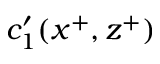Convert formula to latex. <formula><loc_0><loc_0><loc_500><loc_500>c _ { 1 } ^ { \prime } ( x ^ { + } , z ^ { + } )</formula> 